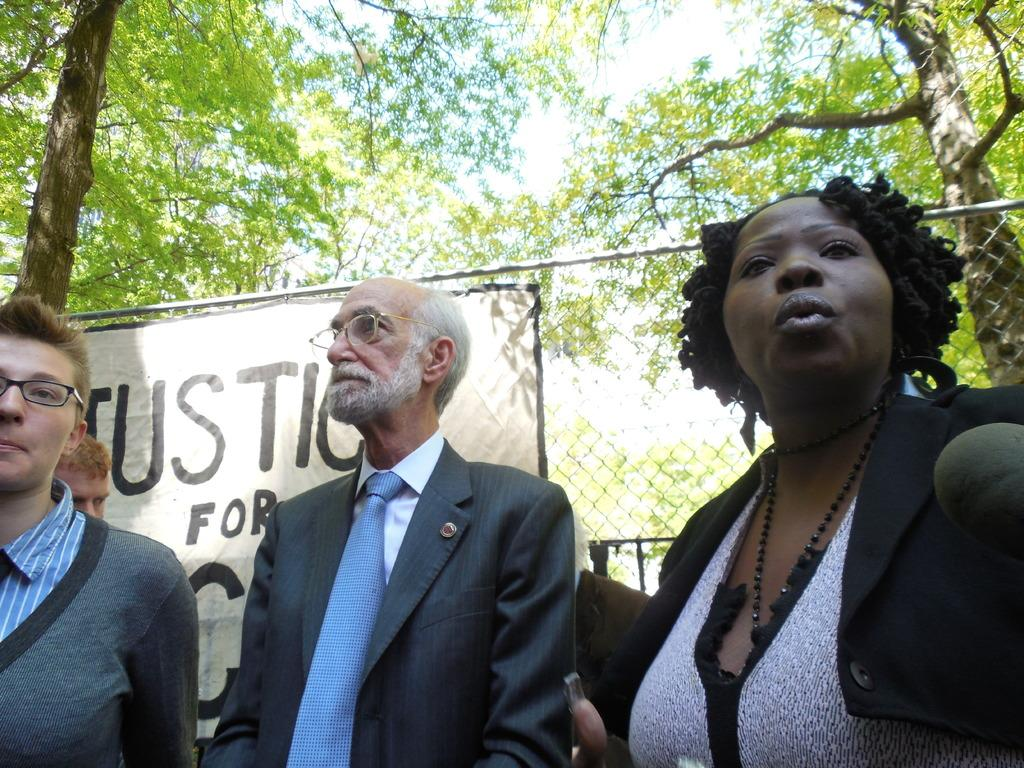How many people can be seen in the image? There are many people in the image. Can you describe any specific features of the people? Some of the people are wearing glasses (specs). What can be seen in the background of the image? There is a fencing with a banner and trees in the background. Reasoning: Let's think step by step by step in order to produce the conversation. We start by identifying the main subject of the image, which is the people. Then, we describe a specific feature of some of the people, which is that they are wearing glasses. Finally, we mention the background elements, which include a fencing with a banner and trees. Absurd Question/Answer: What type of drink is being served to the pigs in the image? There are no pigs or drinks present in the image. 